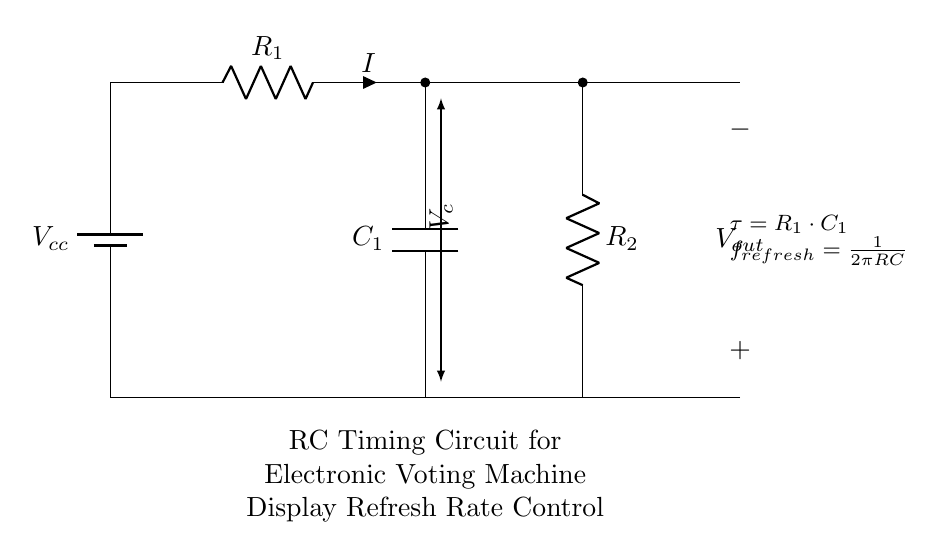What does Vcc represent in the circuit? Vcc indicates the supply voltage for the circuit, providing the necessary power for operation.
Answer: Supply voltage What is the function of capacitor C1 in this circuit? The capacitor C1 is used to store charge and control the timing for the display refresh rate by influencing the time constant of the circuit.
Answer: Timing control What is the time constant for this RC circuit? The time constant is calculated using the formula τ = R1 * C1, representing the time it takes for the capacitor to charge to about 63.2% of Vcc.
Answer: R1 * C1 How does increasing R1 affect the refresh rate? Increasing R1 increases the time constant τ, which decreases the refresh rate according to the formula f_refresh = 1/(2πR1C1).
Answer: Decreases refresh rate What is the output voltage labeled as in the circuit? The output voltage is labeled V_out, referring to the voltage across the capacitor.
Answer: V_out If R2 is much smaller than R1, what happens to the overall circuit behavior? If R2 is much smaller than R1, it will mainly allow the capacitor to discharge quickly while having minimal effect on the charging phase.
Answer: Quick discharge 